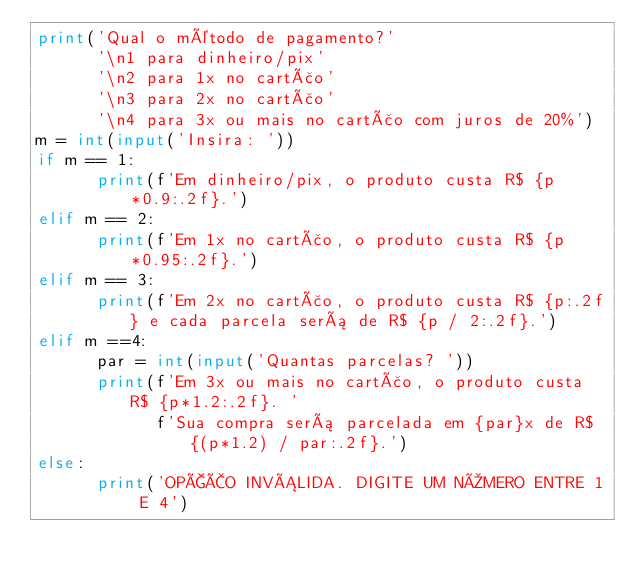<code> <loc_0><loc_0><loc_500><loc_500><_Python_>print('Qual o método de pagamento?'
      '\n1 para dinheiro/pix'
      '\n2 para 1x no cartão'
      '\n3 para 2x no cartão'
      '\n4 para 3x ou mais no cartão com juros de 20%')
m = int(input('Insira: '))
if m == 1:
      print(f'Em dinheiro/pix, o produto custa R$ {p*0.9:.2f}.')
elif m == 2:
      print(f'Em 1x no cartão, o produto custa R$ {p*0.95:.2f}.')
elif m == 3:
      print(f'Em 2x no cartão, o produto custa R$ {p:.2f} e cada parcela será de R$ {p / 2:.2f}.')
elif m ==4:
      par = int(input('Quantas parcelas? '))
      print(f'Em 3x ou mais no cartão, o produto custa R$ {p*1.2:.2f}. '
            f'Sua compra será parcelada em {par}x de R$ {(p*1.2) / par:.2f}.')
else:
      print('OPÇÃO INVÁLIDA. DIGITE UM NÚMERO ENTRE 1 E 4')
</code> 